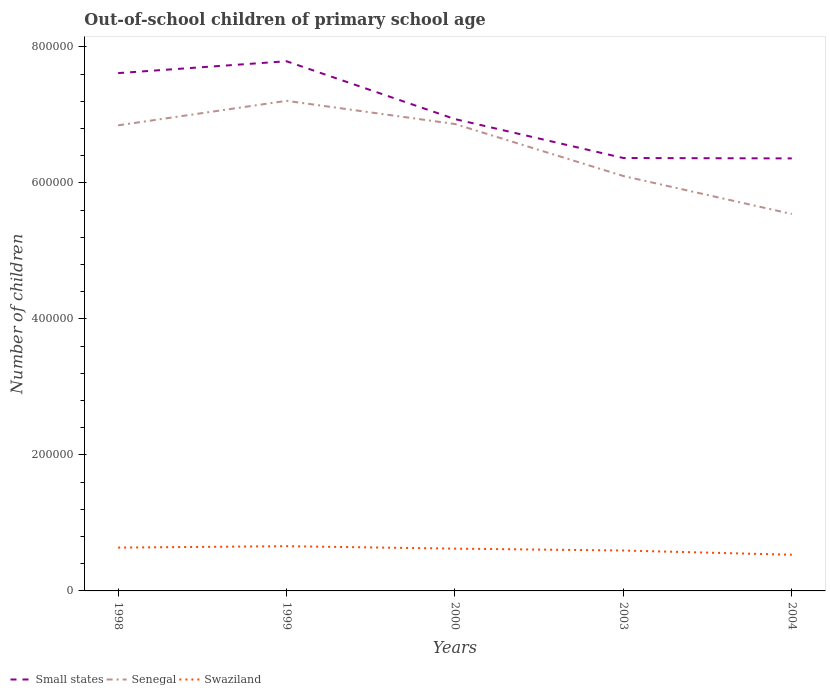Across all years, what is the maximum number of out-of-school children in Senegal?
Your response must be concise. 5.54e+05. In which year was the number of out-of-school children in Swaziland maximum?
Offer a terse response. 2004. What is the total number of out-of-school children in Senegal in the graph?
Provide a succinct answer. 1.11e+05. What is the difference between the highest and the second highest number of out-of-school children in Senegal?
Your answer should be compact. 1.66e+05. What is the difference between the highest and the lowest number of out-of-school children in Small states?
Offer a terse response. 2. How many years are there in the graph?
Offer a terse response. 5. Are the values on the major ticks of Y-axis written in scientific E-notation?
Your response must be concise. No. Does the graph contain grids?
Your answer should be very brief. No. Where does the legend appear in the graph?
Offer a very short reply. Bottom left. What is the title of the graph?
Provide a succinct answer. Out-of-school children of primary school age. Does "Tanzania" appear as one of the legend labels in the graph?
Ensure brevity in your answer.  No. What is the label or title of the X-axis?
Provide a short and direct response. Years. What is the label or title of the Y-axis?
Make the answer very short. Number of children. What is the Number of children of Small states in 1998?
Offer a terse response. 7.61e+05. What is the Number of children of Senegal in 1998?
Your answer should be very brief. 6.85e+05. What is the Number of children of Swaziland in 1998?
Your answer should be very brief. 6.37e+04. What is the Number of children of Small states in 1999?
Ensure brevity in your answer.  7.79e+05. What is the Number of children in Senegal in 1999?
Provide a short and direct response. 7.21e+05. What is the Number of children in Swaziland in 1999?
Your response must be concise. 6.58e+04. What is the Number of children in Small states in 2000?
Provide a short and direct response. 6.94e+05. What is the Number of children of Senegal in 2000?
Offer a terse response. 6.87e+05. What is the Number of children of Swaziland in 2000?
Offer a terse response. 6.22e+04. What is the Number of children in Small states in 2003?
Your answer should be very brief. 6.37e+05. What is the Number of children of Senegal in 2003?
Provide a short and direct response. 6.10e+05. What is the Number of children of Swaziland in 2003?
Keep it short and to the point. 5.94e+04. What is the Number of children of Small states in 2004?
Provide a short and direct response. 6.36e+05. What is the Number of children of Senegal in 2004?
Provide a short and direct response. 5.54e+05. What is the Number of children of Swaziland in 2004?
Keep it short and to the point. 5.32e+04. Across all years, what is the maximum Number of children in Small states?
Ensure brevity in your answer.  7.79e+05. Across all years, what is the maximum Number of children in Senegal?
Provide a succinct answer. 7.21e+05. Across all years, what is the maximum Number of children of Swaziland?
Provide a succinct answer. 6.58e+04. Across all years, what is the minimum Number of children of Small states?
Your response must be concise. 6.36e+05. Across all years, what is the minimum Number of children of Senegal?
Make the answer very short. 5.54e+05. Across all years, what is the minimum Number of children of Swaziland?
Provide a succinct answer. 5.32e+04. What is the total Number of children of Small states in the graph?
Your response must be concise. 3.51e+06. What is the total Number of children of Senegal in the graph?
Your answer should be very brief. 3.26e+06. What is the total Number of children of Swaziland in the graph?
Provide a short and direct response. 3.04e+05. What is the difference between the Number of children of Small states in 1998 and that in 1999?
Give a very brief answer. -1.74e+04. What is the difference between the Number of children in Senegal in 1998 and that in 1999?
Keep it short and to the point. -3.60e+04. What is the difference between the Number of children in Swaziland in 1998 and that in 1999?
Your response must be concise. -2072. What is the difference between the Number of children in Small states in 1998 and that in 2000?
Provide a short and direct response. 6.76e+04. What is the difference between the Number of children of Senegal in 1998 and that in 2000?
Provide a short and direct response. -1941. What is the difference between the Number of children in Swaziland in 1998 and that in 2000?
Provide a short and direct response. 1522. What is the difference between the Number of children in Small states in 1998 and that in 2003?
Offer a very short reply. 1.25e+05. What is the difference between the Number of children in Senegal in 1998 and that in 2003?
Provide a short and direct response. 7.45e+04. What is the difference between the Number of children of Swaziland in 1998 and that in 2003?
Your answer should be very brief. 4292. What is the difference between the Number of children in Small states in 1998 and that in 2004?
Your answer should be very brief. 1.25e+05. What is the difference between the Number of children of Senegal in 1998 and that in 2004?
Offer a very short reply. 1.30e+05. What is the difference between the Number of children of Swaziland in 1998 and that in 2004?
Offer a terse response. 1.05e+04. What is the difference between the Number of children of Small states in 1999 and that in 2000?
Ensure brevity in your answer.  8.51e+04. What is the difference between the Number of children in Senegal in 1999 and that in 2000?
Give a very brief answer. 3.41e+04. What is the difference between the Number of children in Swaziland in 1999 and that in 2000?
Keep it short and to the point. 3594. What is the difference between the Number of children of Small states in 1999 and that in 2003?
Offer a terse response. 1.42e+05. What is the difference between the Number of children of Senegal in 1999 and that in 2003?
Provide a succinct answer. 1.11e+05. What is the difference between the Number of children of Swaziland in 1999 and that in 2003?
Provide a short and direct response. 6364. What is the difference between the Number of children of Small states in 1999 and that in 2004?
Offer a very short reply. 1.43e+05. What is the difference between the Number of children in Senegal in 1999 and that in 2004?
Your answer should be very brief. 1.66e+05. What is the difference between the Number of children in Swaziland in 1999 and that in 2004?
Provide a succinct answer. 1.26e+04. What is the difference between the Number of children in Small states in 2000 and that in 2003?
Make the answer very short. 5.72e+04. What is the difference between the Number of children of Senegal in 2000 and that in 2003?
Keep it short and to the point. 7.65e+04. What is the difference between the Number of children of Swaziland in 2000 and that in 2003?
Your answer should be very brief. 2770. What is the difference between the Number of children in Small states in 2000 and that in 2004?
Your answer should be very brief. 5.78e+04. What is the difference between the Number of children of Senegal in 2000 and that in 2004?
Your response must be concise. 1.32e+05. What is the difference between the Number of children of Swaziland in 2000 and that in 2004?
Ensure brevity in your answer.  8997. What is the difference between the Number of children of Small states in 2003 and that in 2004?
Provide a short and direct response. 569. What is the difference between the Number of children in Senegal in 2003 and that in 2004?
Offer a terse response. 5.58e+04. What is the difference between the Number of children of Swaziland in 2003 and that in 2004?
Provide a succinct answer. 6227. What is the difference between the Number of children of Small states in 1998 and the Number of children of Senegal in 1999?
Keep it short and to the point. 4.08e+04. What is the difference between the Number of children of Small states in 1998 and the Number of children of Swaziland in 1999?
Offer a very short reply. 6.96e+05. What is the difference between the Number of children in Senegal in 1998 and the Number of children in Swaziland in 1999?
Provide a succinct answer. 6.19e+05. What is the difference between the Number of children of Small states in 1998 and the Number of children of Senegal in 2000?
Your answer should be compact. 7.49e+04. What is the difference between the Number of children of Small states in 1998 and the Number of children of Swaziland in 2000?
Offer a terse response. 6.99e+05. What is the difference between the Number of children in Senegal in 1998 and the Number of children in Swaziland in 2000?
Provide a succinct answer. 6.22e+05. What is the difference between the Number of children in Small states in 1998 and the Number of children in Senegal in 2003?
Offer a terse response. 1.51e+05. What is the difference between the Number of children of Small states in 1998 and the Number of children of Swaziland in 2003?
Your answer should be compact. 7.02e+05. What is the difference between the Number of children of Senegal in 1998 and the Number of children of Swaziland in 2003?
Your answer should be compact. 6.25e+05. What is the difference between the Number of children of Small states in 1998 and the Number of children of Senegal in 2004?
Your response must be concise. 2.07e+05. What is the difference between the Number of children in Small states in 1998 and the Number of children in Swaziland in 2004?
Keep it short and to the point. 7.08e+05. What is the difference between the Number of children of Senegal in 1998 and the Number of children of Swaziland in 2004?
Offer a terse response. 6.31e+05. What is the difference between the Number of children in Small states in 1999 and the Number of children in Senegal in 2000?
Give a very brief answer. 9.23e+04. What is the difference between the Number of children in Small states in 1999 and the Number of children in Swaziland in 2000?
Your answer should be compact. 7.17e+05. What is the difference between the Number of children of Senegal in 1999 and the Number of children of Swaziland in 2000?
Offer a very short reply. 6.59e+05. What is the difference between the Number of children of Small states in 1999 and the Number of children of Senegal in 2003?
Ensure brevity in your answer.  1.69e+05. What is the difference between the Number of children in Small states in 1999 and the Number of children in Swaziland in 2003?
Your answer should be very brief. 7.19e+05. What is the difference between the Number of children in Senegal in 1999 and the Number of children in Swaziland in 2003?
Offer a terse response. 6.61e+05. What is the difference between the Number of children in Small states in 1999 and the Number of children in Senegal in 2004?
Keep it short and to the point. 2.25e+05. What is the difference between the Number of children in Small states in 1999 and the Number of children in Swaziland in 2004?
Offer a very short reply. 7.26e+05. What is the difference between the Number of children of Senegal in 1999 and the Number of children of Swaziland in 2004?
Offer a very short reply. 6.68e+05. What is the difference between the Number of children of Small states in 2000 and the Number of children of Senegal in 2003?
Offer a terse response. 8.37e+04. What is the difference between the Number of children of Small states in 2000 and the Number of children of Swaziland in 2003?
Offer a terse response. 6.34e+05. What is the difference between the Number of children of Senegal in 2000 and the Number of children of Swaziland in 2003?
Provide a succinct answer. 6.27e+05. What is the difference between the Number of children of Small states in 2000 and the Number of children of Senegal in 2004?
Provide a succinct answer. 1.40e+05. What is the difference between the Number of children in Small states in 2000 and the Number of children in Swaziland in 2004?
Keep it short and to the point. 6.41e+05. What is the difference between the Number of children of Senegal in 2000 and the Number of children of Swaziland in 2004?
Offer a very short reply. 6.33e+05. What is the difference between the Number of children in Small states in 2003 and the Number of children in Senegal in 2004?
Your answer should be compact. 8.23e+04. What is the difference between the Number of children of Small states in 2003 and the Number of children of Swaziland in 2004?
Your answer should be compact. 5.83e+05. What is the difference between the Number of children in Senegal in 2003 and the Number of children in Swaziland in 2004?
Your response must be concise. 5.57e+05. What is the average Number of children of Small states per year?
Provide a short and direct response. 7.01e+05. What is the average Number of children of Senegal per year?
Make the answer very short. 6.51e+05. What is the average Number of children of Swaziland per year?
Your response must be concise. 6.09e+04. In the year 1998, what is the difference between the Number of children of Small states and Number of children of Senegal?
Your answer should be very brief. 7.68e+04. In the year 1998, what is the difference between the Number of children in Small states and Number of children in Swaziland?
Your answer should be compact. 6.98e+05. In the year 1998, what is the difference between the Number of children in Senegal and Number of children in Swaziland?
Your answer should be compact. 6.21e+05. In the year 1999, what is the difference between the Number of children of Small states and Number of children of Senegal?
Offer a very short reply. 5.82e+04. In the year 1999, what is the difference between the Number of children of Small states and Number of children of Swaziland?
Offer a terse response. 7.13e+05. In the year 1999, what is the difference between the Number of children of Senegal and Number of children of Swaziland?
Ensure brevity in your answer.  6.55e+05. In the year 2000, what is the difference between the Number of children in Small states and Number of children in Senegal?
Make the answer very short. 7233. In the year 2000, what is the difference between the Number of children of Small states and Number of children of Swaziland?
Your response must be concise. 6.32e+05. In the year 2000, what is the difference between the Number of children of Senegal and Number of children of Swaziland?
Provide a short and direct response. 6.24e+05. In the year 2003, what is the difference between the Number of children of Small states and Number of children of Senegal?
Provide a succinct answer. 2.65e+04. In the year 2003, what is the difference between the Number of children of Small states and Number of children of Swaziland?
Offer a terse response. 5.77e+05. In the year 2003, what is the difference between the Number of children in Senegal and Number of children in Swaziland?
Your response must be concise. 5.51e+05. In the year 2004, what is the difference between the Number of children of Small states and Number of children of Senegal?
Give a very brief answer. 8.18e+04. In the year 2004, what is the difference between the Number of children in Small states and Number of children in Swaziland?
Provide a short and direct response. 5.83e+05. In the year 2004, what is the difference between the Number of children of Senegal and Number of children of Swaziland?
Keep it short and to the point. 5.01e+05. What is the ratio of the Number of children in Small states in 1998 to that in 1999?
Provide a succinct answer. 0.98. What is the ratio of the Number of children in Senegal in 1998 to that in 1999?
Your answer should be compact. 0.95. What is the ratio of the Number of children of Swaziland in 1998 to that in 1999?
Give a very brief answer. 0.97. What is the ratio of the Number of children of Small states in 1998 to that in 2000?
Keep it short and to the point. 1.1. What is the ratio of the Number of children in Senegal in 1998 to that in 2000?
Your response must be concise. 1. What is the ratio of the Number of children in Swaziland in 1998 to that in 2000?
Your response must be concise. 1.02. What is the ratio of the Number of children of Small states in 1998 to that in 2003?
Ensure brevity in your answer.  1.2. What is the ratio of the Number of children of Senegal in 1998 to that in 2003?
Make the answer very short. 1.12. What is the ratio of the Number of children of Swaziland in 1998 to that in 2003?
Your answer should be compact. 1.07. What is the ratio of the Number of children of Small states in 1998 to that in 2004?
Your response must be concise. 1.2. What is the ratio of the Number of children in Senegal in 1998 to that in 2004?
Offer a very short reply. 1.24. What is the ratio of the Number of children of Swaziland in 1998 to that in 2004?
Offer a very short reply. 1.2. What is the ratio of the Number of children in Small states in 1999 to that in 2000?
Provide a short and direct response. 1.12. What is the ratio of the Number of children in Senegal in 1999 to that in 2000?
Your answer should be compact. 1.05. What is the ratio of the Number of children of Swaziland in 1999 to that in 2000?
Keep it short and to the point. 1.06. What is the ratio of the Number of children of Small states in 1999 to that in 2003?
Offer a very short reply. 1.22. What is the ratio of the Number of children in Senegal in 1999 to that in 2003?
Make the answer very short. 1.18. What is the ratio of the Number of children in Swaziland in 1999 to that in 2003?
Offer a terse response. 1.11. What is the ratio of the Number of children of Small states in 1999 to that in 2004?
Your answer should be very brief. 1.22. What is the ratio of the Number of children in Senegal in 1999 to that in 2004?
Your answer should be very brief. 1.3. What is the ratio of the Number of children in Swaziland in 1999 to that in 2004?
Your answer should be very brief. 1.24. What is the ratio of the Number of children in Small states in 2000 to that in 2003?
Offer a terse response. 1.09. What is the ratio of the Number of children of Senegal in 2000 to that in 2003?
Provide a short and direct response. 1.13. What is the ratio of the Number of children of Swaziland in 2000 to that in 2003?
Keep it short and to the point. 1.05. What is the ratio of the Number of children in Senegal in 2000 to that in 2004?
Ensure brevity in your answer.  1.24. What is the ratio of the Number of children of Swaziland in 2000 to that in 2004?
Offer a terse response. 1.17. What is the ratio of the Number of children in Senegal in 2003 to that in 2004?
Offer a terse response. 1.1. What is the ratio of the Number of children of Swaziland in 2003 to that in 2004?
Make the answer very short. 1.12. What is the difference between the highest and the second highest Number of children in Small states?
Your answer should be compact. 1.74e+04. What is the difference between the highest and the second highest Number of children in Senegal?
Make the answer very short. 3.41e+04. What is the difference between the highest and the second highest Number of children in Swaziland?
Ensure brevity in your answer.  2072. What is the difference between the highest and the lowest Number of children in Small states?
Provide a succinct answer. 1.43e+05. What is the difference between the highest and the lowest Number of children in Senegal?
Keep it short and to the point. 1.66e+05. What is the difference between the highest and the lowest Number of children of Swaziland?
Your answer should be very brief. 1.26e+04. 